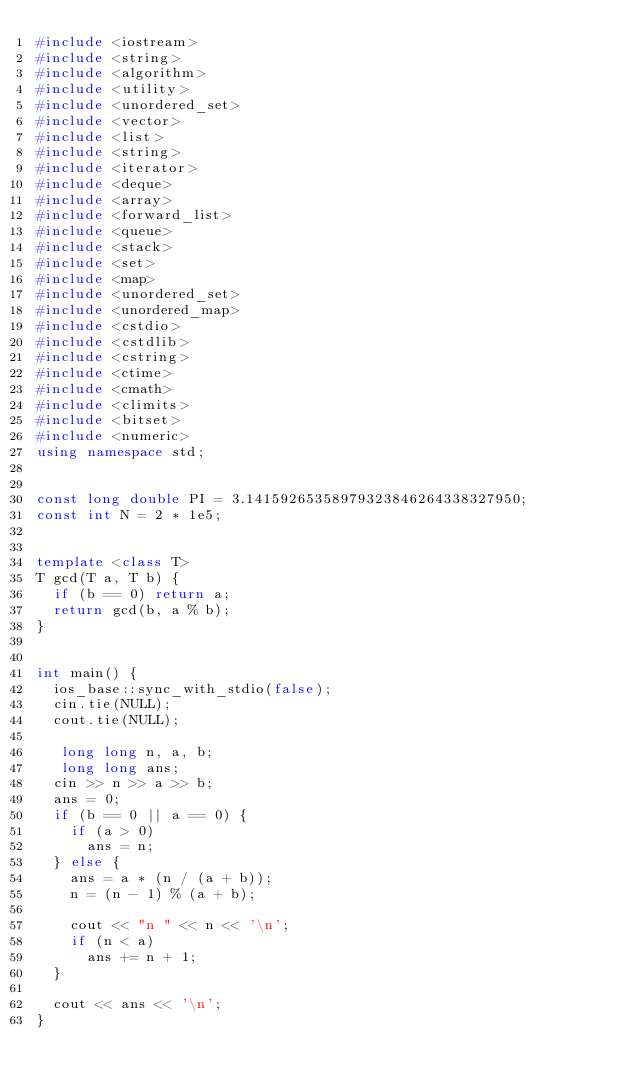<code> <loc_0><loc_0><loc_500><loc_500><_C++_>#include <iostream>
#include <string>
#include <algorithm>
#include <utility> 
#include <unordered_set>
#include <vector>
#include <list> 
#include <string>
#include <iterator> 
#include <deque>
#include <array>
#include <forward_list>
#include <queue>
#include <stack>
#include <set>
#include <map>
#include <unordered_set>
#include <unordered_map>
#include <cstdio>
#include <cstdlib>
#include <cstring>
#include <ctime>
#include <cmath>
#include <climits>
#include <bitset>
#include <numeric>
using namespace std;


const long double PI = 3.14159265358979323846264338327950;
const int N = 2 * 1e5;


template <class T>
T gcd(T a, T b) {
	if (b == 0) return a;
	return gcd(b, a % b);
}


int main() {
	ios_base::sync_with_stdio(false);
	cin.tie(NULL);
	cout.tie(NULL);

	 long long n, a, b;
	 long long ans;
	cin >> n >> a >> b;
	ans = 0;
	if (b == 0 || a == 0) {
		if (a > 0)
			ans = n;
	} else {
		ans = a * (n / (a + b));
		n = (n - 1) % (a + b);

		cout << "n " << n << '\n';
		if (n < a)
			ans += n + 1;
	}

	cout << ans << '\n';
}
</code> 